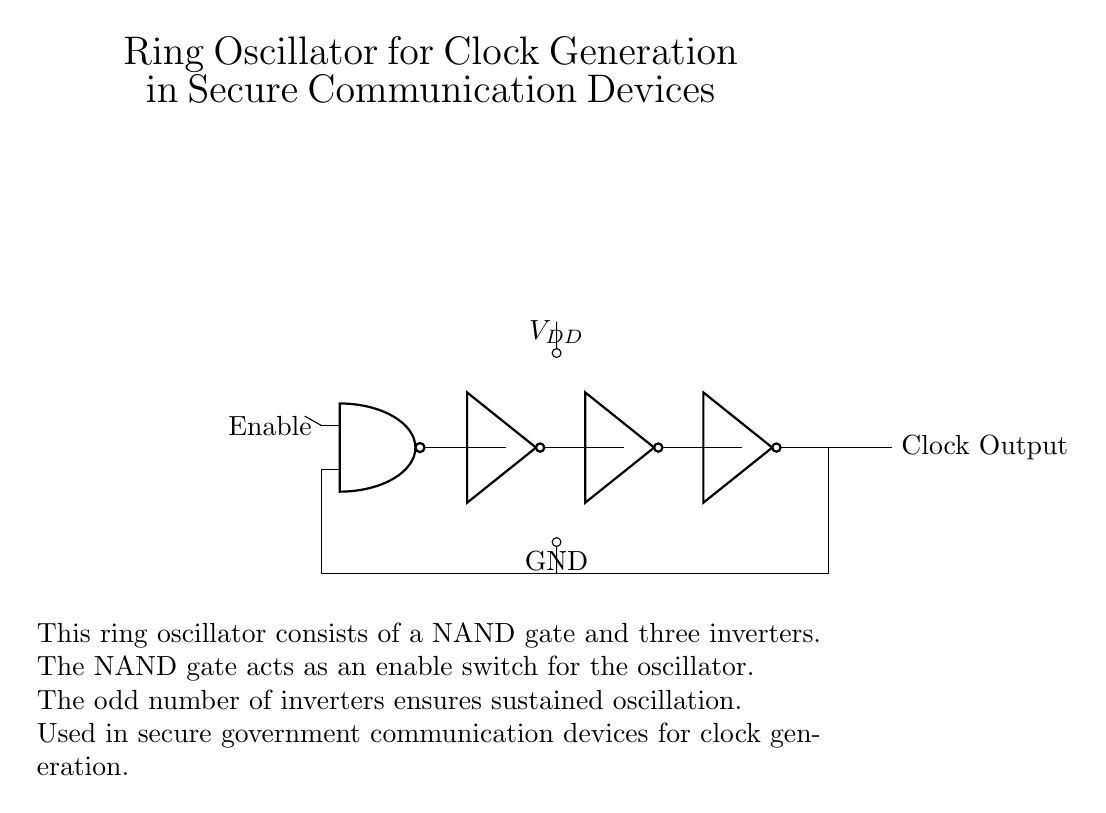What type of gate is used as the enable switch? The circuit utilizes a NAND gate as the enable switch, which allows for controlling the oscillation based on the input signal.
Answer: NAND gate How many inverters are present in the circuit? There are three inverters in the circuit, which are necessary for establishing sustained oscillation within the oscillator design.
Answer: Three What is the purpose of the feedback loop? The feedback loop connects the output of the last inverter back to the input of the NAND gate, which is essential for creating oscillations in the circuit.
Answer: Oscillation What do the labels V_DD and GND represent? V_DD represents the supply voltage for the circuit, while GND signifies the ground reference point for circuit operation.
Answer: Supply voltage and ground Why is an odd number of inverters used? An odd number of inverters is used to ensure that there is a phase shift necessary for oscillation; it creates a feedback loop that sustains continuous oscillations.
Answer: Sustained oscillation 